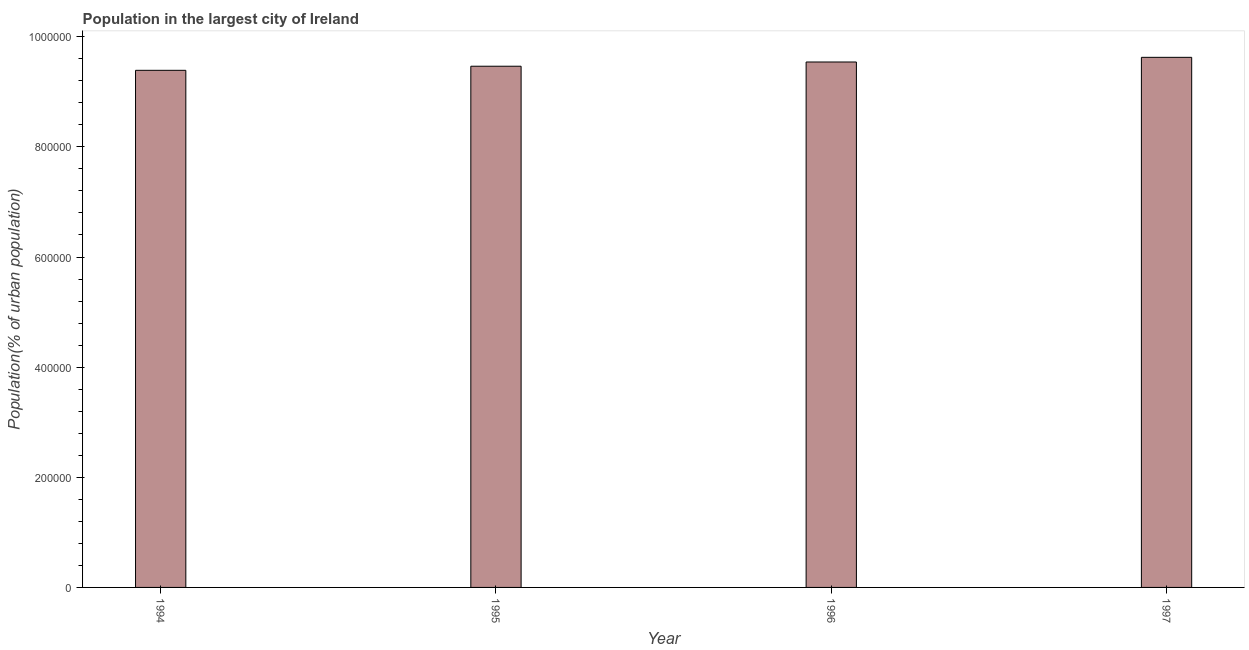Does the graph contain grids?
Keep it short and to the point. No. What is the title of the graph?
Offer a very short reply. Population in the largest city of Ireland. What is the label or title of the Y-axis?
Your answer should be compact. Population(% of urban population). What is the population in largest city in 1994?
Make the answer very short. 9.39e+05. Across all years, what is the maximum population in largest city?
Offer a terse response. 9.63e+05. Across all years, what is the minimum population in largest city?
Your answer should be compact. 9.39e+05. What is the sum of the population in largest city?
Your answer should be compact. 3.80e+06. What is the difference between the population in largest city in 1995 and 1997?
Your answer should be very brief. -1.61e+04. What is the average population in largest city per year?
Keep it short and to the point. 9.51e+05. What is the median population in largest city?
Make the answer very short. 9.50e+05. What is the ratio of the population in largest city in 1994 to that in 1997?
Keep it short and to the point. 0.97. Is the difference between the population in largest city in 1995 and 1997 greater than the difference between any two years?
Provide a short and direct response. No. What is the difference between the highest and the second highest population in largest city?
Offer a very short reply. 8467. What is the difference between the highest and the lowest population in largest city?
Your answer should be very brief. 2.36e+04. In how many years, is the population in largest city greater than the average population in largest city taken over all years?
Your answer should be compact. 2. Are all the bars in the graph horizontal?
Provide a short and direct response. No. How many years are there in the graph?
Your answer should be compact. 4. What is the difference between two consecutive major ticks on the Y-axis?
Provide a succinct answer. 2.00e+05. Are the values on the major ticks of Y-axis written in scientific E-notation?
Offer a very short reply. No. What is the Population(% of urban population) in 1994?
Offer a terse response. 9.39e+05. What is the Population(% of urban population) of 1995?
Offer a terse response. 9.46e+05. What is the Population(% of urban population) of 1996?
Give a very brief answer. 9.54e+05. What is the Population(% of urban population) of 1997?
Your answer should be very brief. 9.63e+05. What is the difference between the Population(% of urban population) in 1994 and 1995?
Your response must be concise. -7449. What is the difference between the Population(% of urban population) in 1994 and 1996?
Offer a very short reply. -1.51e+04. What is the difference between the Population(% of urban population) in 1994 and 1997?
Make the answer very short. -2.36e+04. What is the difference between the Population(% of urban population) in 1995 and 1996?
Ensure brevity in your answer.  -7677. What is the difference between the Population(% of urban population) in 1995 and 1997?
Ensure brevity in your answer.  -1.61e+04. What is the difference between the Population(% of urban population) in 1996 and 1997?
Offer a terse response. -8467. What is the ratio of the Population(% of urban population) in 1994 to that in 1996?
Your answer should be very brief. 0.98. What is the ratio of the Population(% of urban population) in 1995 to that in 1996?
Give a very brief answer. 0.99. What is the ratio of the Population(% of urban population) in 1996 to that in 1997?
Your answer should be very brief. 0.99. 